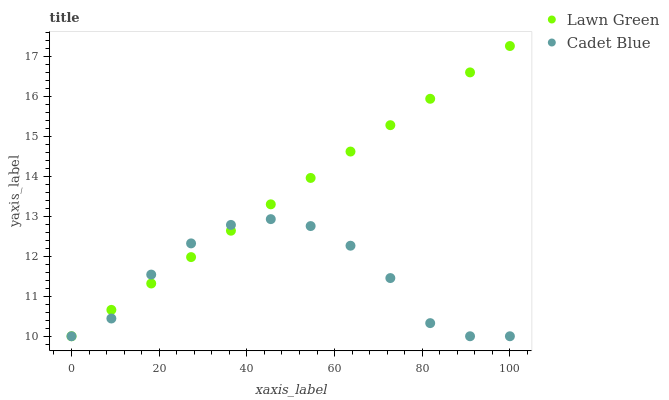Does Cadet Blue have the minimum area under the curve?
Answer yes or no. Yes. Does Lawn Green have the maximum area under the curve?
Answer yes or no. Yes. Does Cadet Blue have the maximum area under the curve?
Answer yes or no. No. Is Lawn Green the smoothest?
Answer yes or no. Yes. Is Cadet Blue the roughest?
Answer yes or no. Yes. Is Cadet Blue the smoothest?
Answer yes or no. No. Does Lawn Green have the lowest value?
Answer yes or no. Yes. Does Lawn Green have the highest value?
Answer yes or no. Yes. Does Cadet Blue have the highest value?
Answer yes or no. No. Does Lawn Green intersect Cadet Blue?
Answer yes or no. Yes. Is Lawn Green less than Cadet Blue?
Answer yes or no. No. Is Lawn Green greater than Cadet Blue?
Answer yes or no. No. 